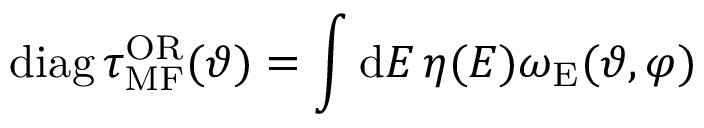Convert formula to latex. <formula><loc_0><loc_0><loc_500><loc_500>d i a g \, \tau _ { M F } ^ { O R } ( \vartheta ) = \int d E \, \eta ( E ) \omega _ { E } ( \vartheta , \varphi )</formula> 